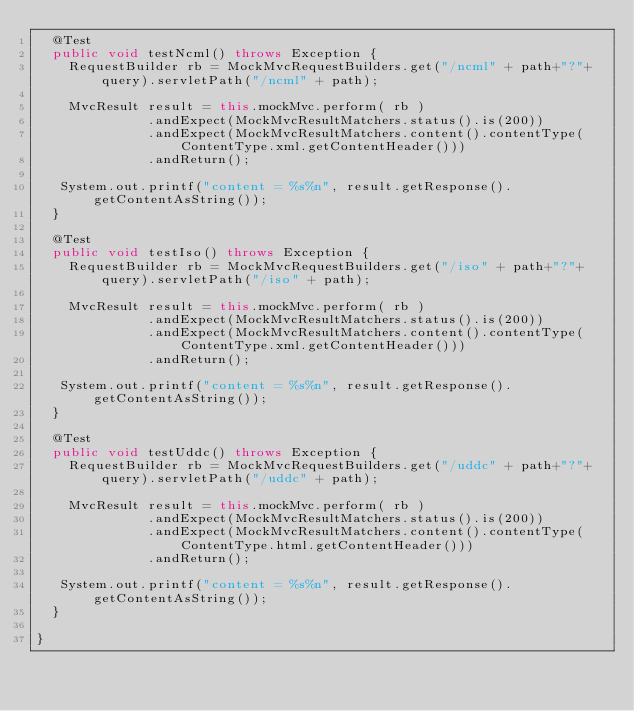<code> <loc_0><loc_0><loc_500><loc_500><_Java_>  @Test
  public void testNcml() throws Exception {
    RequestBuilder rb = MockMvcRequestBuilders.get("/ncml" + path+"?"+query).servletPath("/ncml" + path);

    MvcResult result = this.mockMvc.perform( rb )
              .andExpect(MockMvcResultMatchers.status().is(200))
              .andExpect(MockMvcResultMatchers.content().contentType(ContentType.xml.getContentHeader()))
              .andReturn();

   System.out.printf("content = %s%n", result.getResponse().getContentAsString());
  }

  @Test
  public void testIso() throws Exception {
    RequestBuilder rb = MockMvcRequestBuilders.get("/iso" + path+"?"+query).servletPath("/iso" + path);

    MvcResult result = this.mockMvc.perform( rb )
              .andExpect(MockMvcResultMatchers.status().is(200))
              .andExpect(MockMvcResultMatchers.content().contentType(ContentType.xml.getContentHeader()))
              .andReturn();

   System.out.printf("content = %s%n", result.getResponse().getContentAsString());
  }

  @Test
  public void testUddc() throws Exception {
    RequestBuilder rb = MockMvcRequestBuilders.get("/uddc" + path+"?"+query).servletPath("/uddc" + path);

    MvcResult result = this.mockMvc.perform( rb )
              .andExpect(MockMvcResultMatchers.status().is(200))
              .andExpect(MockMvcResultMatchers.content().contentType(ContentType.html.getContentHeader()))
              .andReturn();

   System.out.printf("content = %s%n", result.getResponse().getContentAsString());
  }

}</code> 